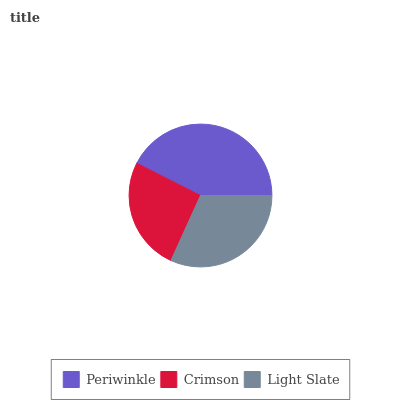Is Crimson the minimum?
Answer yes or no. Yes. Is Periwinkle the maximum?
Answer yes or no. Yes. Is Light Slate the minimum?
Answer yes or no. No. Is Light Slate the maximum?
Answer yes or no. No. Is Light Slate greater than Crimson?
Answer yes or no. Yes. Is Crimson less than Light Slate?
Answer yes or no. Yes. Is Crimson greater than Light Slate?
Answer yes or no. No. Is Light Slate less than Crimson?
Answer yes or no. No. Is Light Slate the high median?
Answer yes or no. Yes. Is Light Slate the low median?
Answer yes or no. Yes. Is Crimson the high median?
Answer yes or no. No. Is Periwinkle the low median?
Answer yes or no. No. 